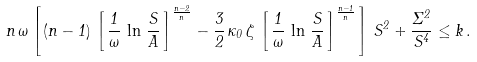Convert formula to latex. <formula><loc_0><loc_0><loc_500><loc_500>n \, \omega \left [ \, ( n - 1 ) \, \left [ \, \frac { 1 } { \omega } \, \ln \, \frac { S } { A } \, \right ] ^ { \frac { n - 2 } { n } } - \frac { 3 } { 2 } \, \kappa _ { 0 } \, \zeta \, \left [ \, \frac { 1 } { \omega } \, \ln \, \frac { S } { A } \, \right ] ^ { \frac { n - 1 } { n } } \, \right ] \, S ^ { 2 } + \frac { \Sigma ^ { 2 } } { S ^ { 4 } } \leq k \, .</formula> 